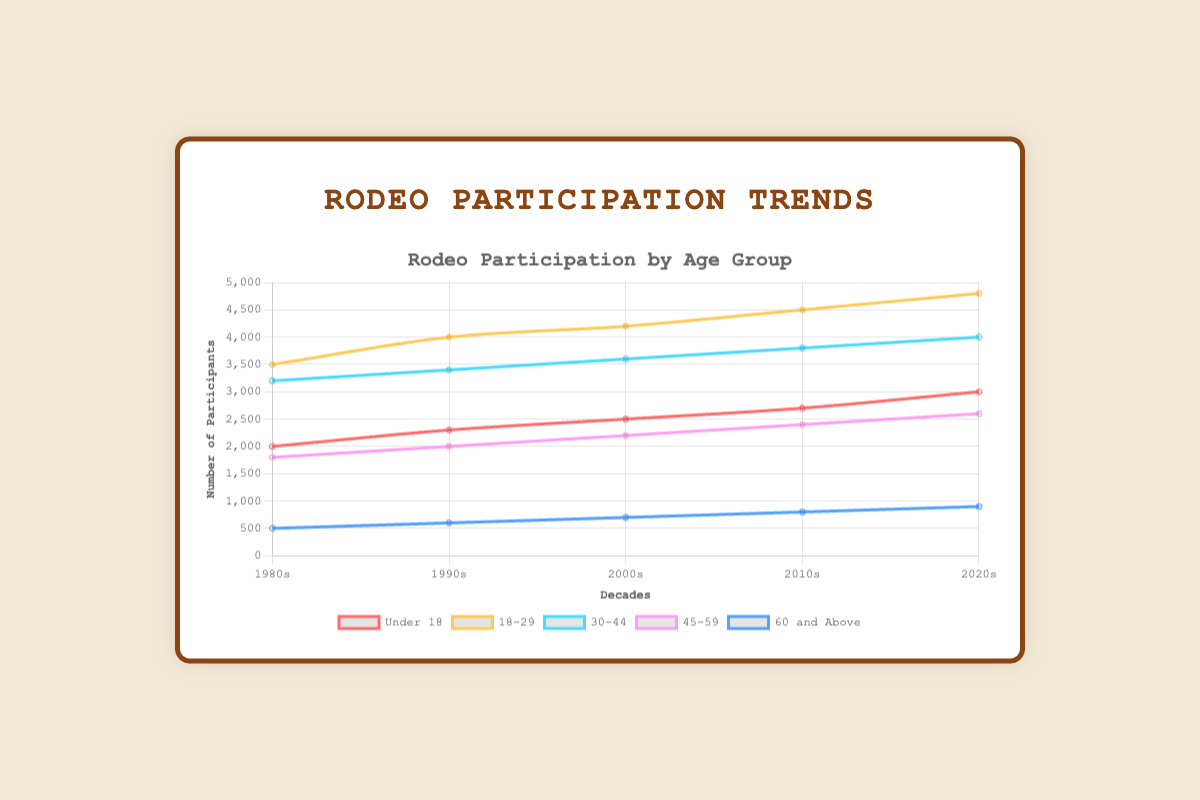Which age group had the highest number of participants in the 2020s? The '18-29' age group is the highest at 4800 participants, based on observing the peak position in the line plots for that decade.
Answer: 18-29 How did participation numbers for the 'Under 18' age group change from the 1980s to the 2020s? Calculate the change by subtracting the 1980s value from the 2020s value: 3000 (2020s) - 2000 (1980s) = 1000 increase.
Answer: Increased by 1000 Which decade saw the biggest increase in participation for the '30-44' age group? By comparing successive values, the largest jump was between the 1980s (3200) and the 1990s (3400), then '00s (3600), '10s (3800), and '20s (4000). The '90s to '00s and '00s to '10s increases were also 200, same as '80s to '90s.
Answer: 1980s to 1990s What is the sum of participants in the '45-59' age group across all decades? Add the values across all decades: 1800 (1980s) + 2000 (1990s) + 2200 (2000s) + 2400 (2010s) + 2600 (2020s) = 11000 participants.
Answer: 11000 Which age group showed the most consistent growth pattern from the 1980s to the 2020s? The '18-29' group shows a consistent linear increase from each decade: 3500 (1980s) to 4000 (1990s), to 4200 (2000s), to 4500 (2010s), to 4800 (2020s).
Answer: 18-29 How much higher was the '60 and Above' participation in the 2020s compared to the 1980s? Subtract the 1980s value from the 2020s value: 900 (2020s) - 500 (1980s) = 400 more participants.
Answer: 400 Which two age groups had the closest participation numbers in the 2000s? The '30-44' and '45-59' age groups are closest with 3600 and 2200 participants, respectively, showing a smaller gap compared to the other groups.
Answer: 30-44 and 45-59 What was the trend for the 'Under 18' age group between the 1990s and the 2010s? From 2300 in the 1990s to 2700 in the 2010s, there is a consistent increase of 200 (1990s to 2000s) and 200 (2000s to 2010s).
Answer: Increasing trend Compare the '60 and Above' group’s participation changes between the 1980s to 1990s and the 2010s to 2020s. The increase from the 1980s (500) to the 1990s (600) was 100, while from the 2010s (800) to the 2020s (900) was also 100. Both changes were equal.
Answer: Equal increase of 100 